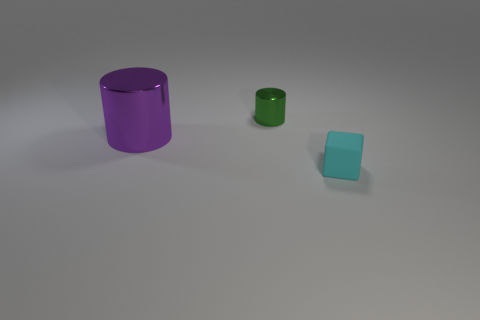Are there any other things that have the same material as the block?
Your answer should be compact. No. There is a object that is on the left side of the tiny cyan cube and right of the purple metallic thing; what material is it made of?
Provide a succinct answer. Metal. The purple object that is made of the same material as the small green thing is what shape?
Make the answer very short. Cylinder. There is a cylinder behind the purple object; what number of cyan rubber blocks are behind it?
Provide a short and direct response. 0. What number of things are to the right of the purple cylinder and behind the cyan rubber thing?
Provide a succinct answer. 1. How many other things are there of the same material as the big thing?
Your answer should be compact. 1. There is a cylinder that is in front of the shiny cylinder that is behind the purple thing; what is its color?
Offer a very short reply. Purple. There is a metal cylinder left of the green shiny cylinder; is its color the same as the rubber thing?
Your answer should be very brief. No. Do the cyan rubber thing and the green metallic cylinder have the same size?
Your answer should be very brief. Yes. There is a green thing that is the same size as the cyan block; what is its shape?
Provide a short and direct response. Cylinder. 